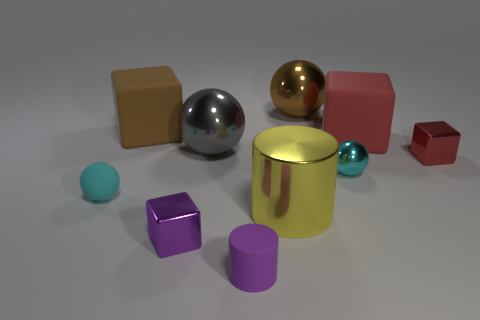Is there a matte ball that has the same color as the small shiny sphere?
Your answer should be compact. Yes. There is a shiny object that is the same color as the tiny rubber sphere; what shape is it?
Offer a terse response. Sphere. Is the large yellow cylinder made of the same material as the cube that is in front of the cyan metallic object?
Offer a terse response. Yes. There is a big brown thing behind the brown cube; is it the same shape as the large gray metallic object?
Provide a succinct answer. Yes. What material is the tiny purple thing that is the same shape as the big yellow object?
Offer a terse response. Rubber. There is a small cyan shiny thing; does it have the same shape as the cyan object that is left of the metal cylinder?
Your answer should be very brief. Yes. There is a ball that is both in front of the tiny red block and right of the big yellow thing; what color is it?
Your response must be concise. Cyan. Is there a small purple ball?
Your answer should be very brief. No. Are there the same number of big cylinders that are behind the tiny cyan matte sphere and yellow rubber cubes?
Offer a very short reply. Yes. What number of other objects are there of the same shape as the large gray thing?
Provide a short and direct response. 3. 